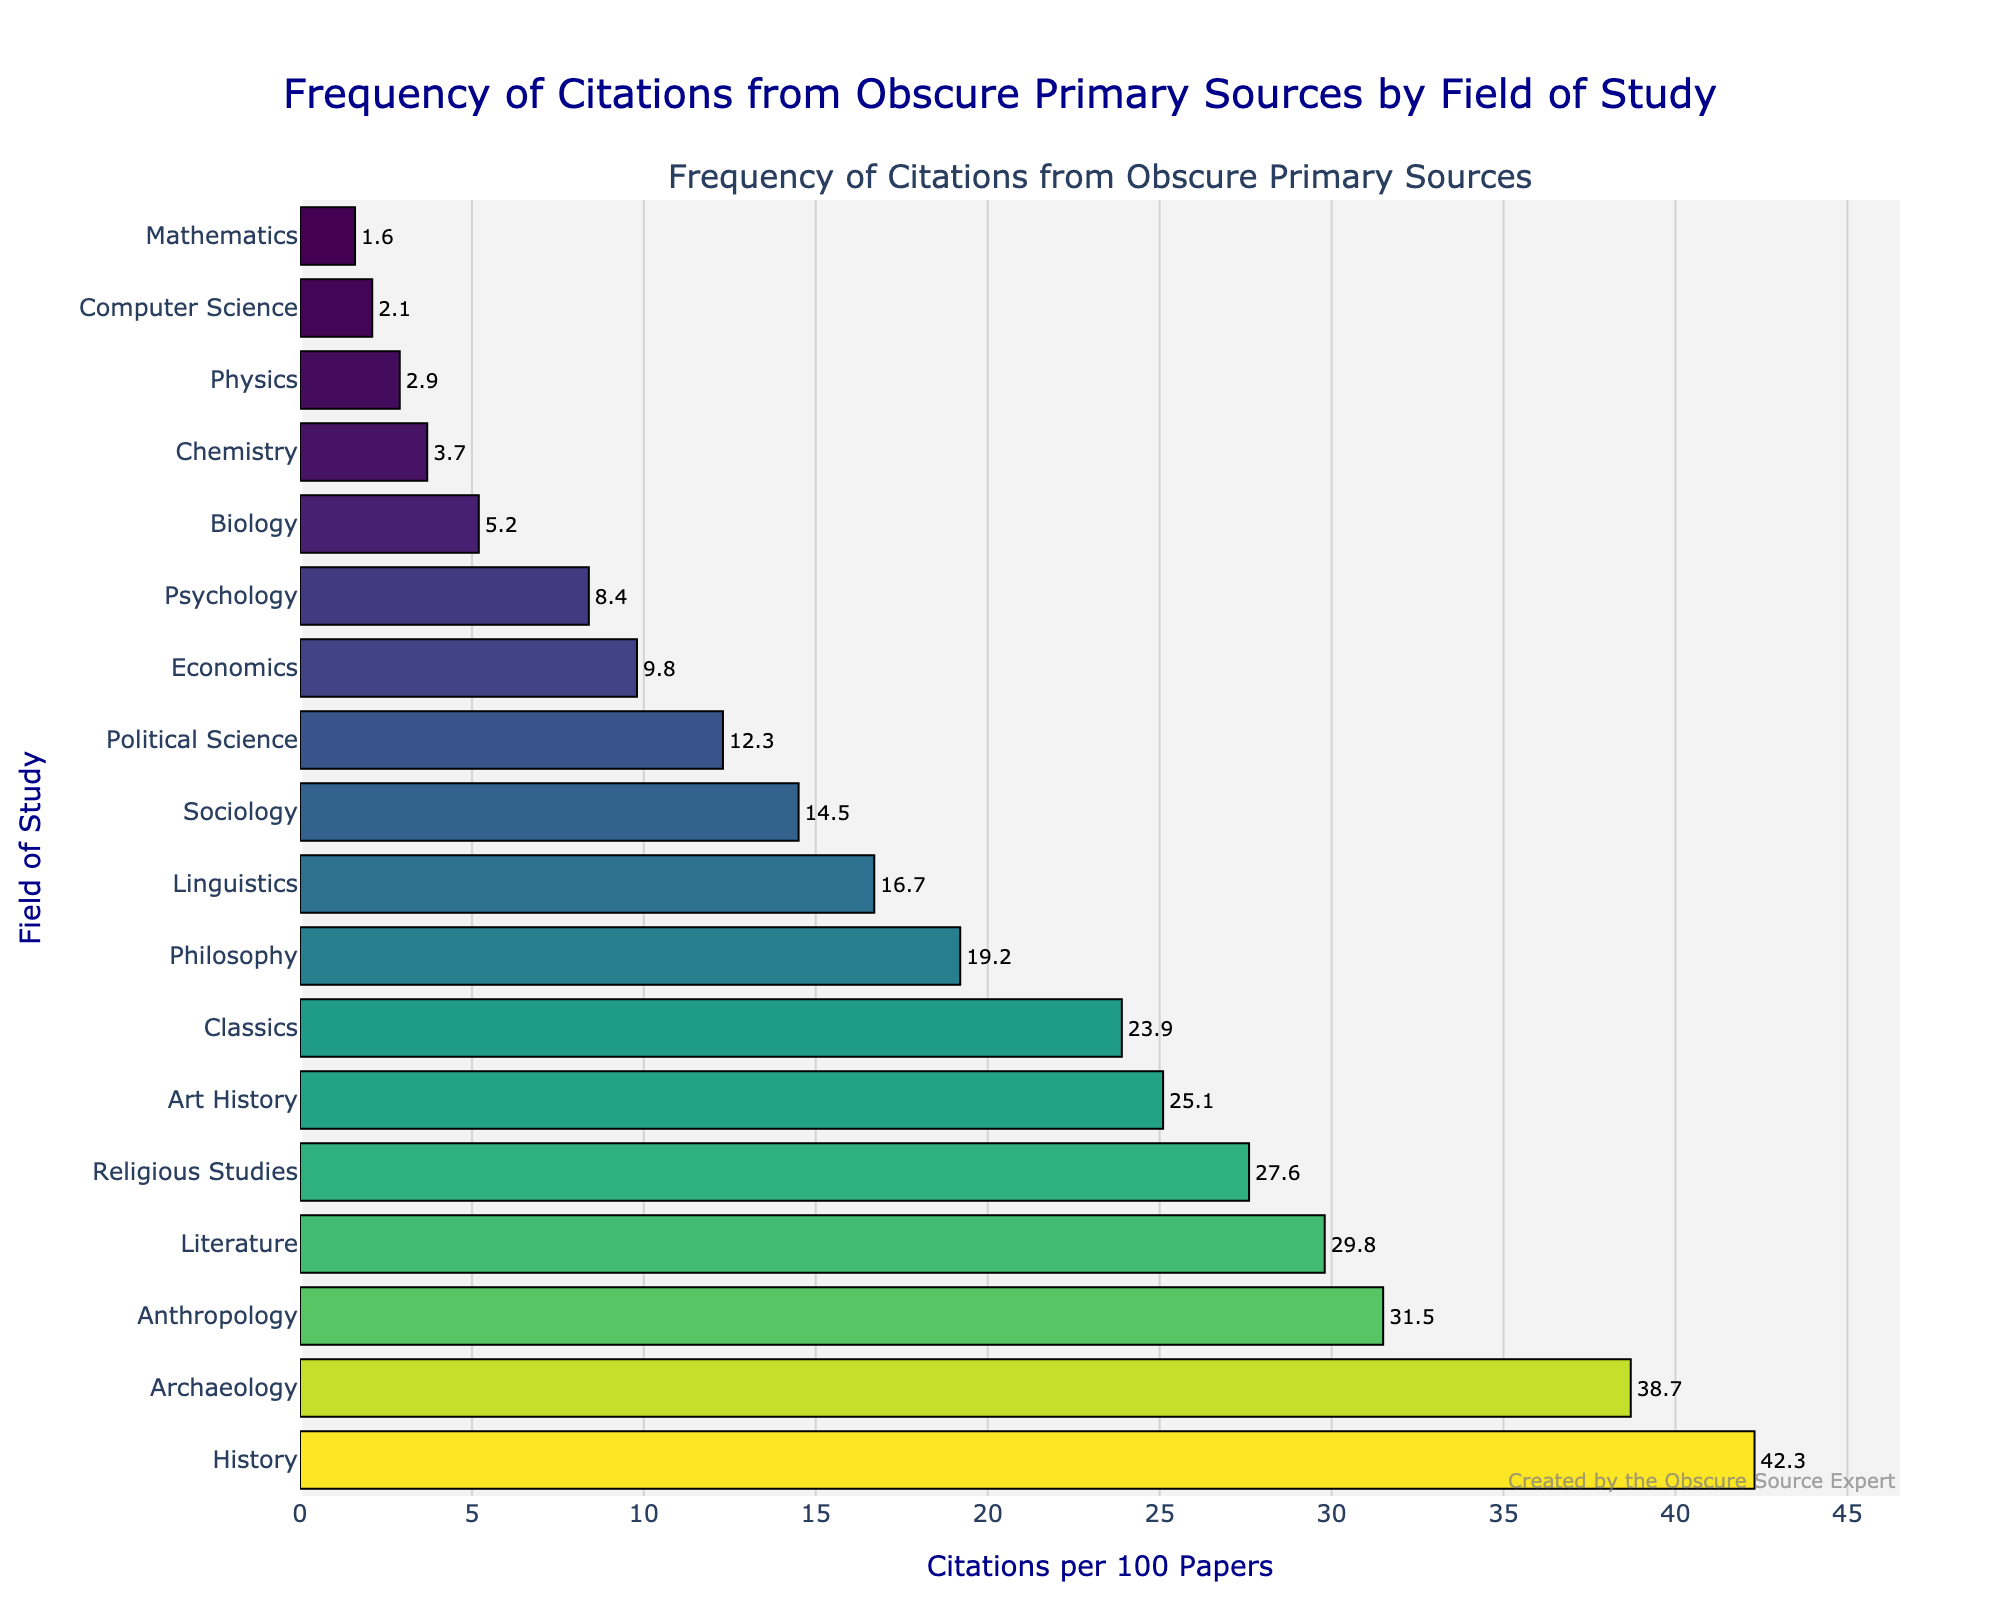What field has the highest frequency of citations from obscure primary sources? The field with the highest bar on the chart represents the highest frequency of citations per 100 papers. By looking at the chart, History has the tallest bar.
Answer: History What's the difference in citation frequency between Anthropology and Sociology? Find the citation frequency for Anthropology and Sociology, then subtract the smaller value from the larger one: Anthropology has 31.5 citations per 100 papers, Sociology has 14.5. Therefore, the difference is 31.5 - 14.5.
Answer: 17 Which field relies least on obscure primary sources according to the chart? Identify the field with the shortest bar on the chart. Mathematics has the shortest bar.
Answer: Mathematics How many fields have a citation frequency greater than 20 per 100 papers? Count the number of fields with bars that correspond to citation values above 20. The fields are History, Archaeology, Anthropology, Literature, and Religious Studies, making it 5 fields.
Answer: 5 What is the median citation frequency across all the fields? List all citation frequencies in ascending order and find the middle value. The sorted frequencies are: 1.6, 2.1, 2.9, 3.7, 5.2, 8.4, 9.8, 12.3, 14.5, 16.7, 19.2, 23.9, 25.1, 27.6, 29.8, 31.5, 38.7, 42.3. With 18 values, the median is the average of the 9th and 10th values: (14.5 + 16.7) / 2.
Answer: 15.6 By how much does the citation frequency in Philosophy exceed that in Chemistry? Find the citation frequencies for both fields and subtract the smaller value from the larger one. Philosophy has 19.2 citations, and Chemistry has 3.7 citations; the difference is 19.2 - 3.7.
Answer: 15.5 Which fields have a citation frequency less than half of the citation frequency of Archaeology? First, calculate half of Archaeology's frequency: 38.7 / 2 = 19.35. Then, identify fields with citation frequencies below 19.35. They are Linguistics, Sociology, Political Science, Economics, Psychology, Biology, Chemistry, Physics, Computer Science, and Mathematics.
Answer: 10 fields What's the average citation frequency of the fields Religious Studies, Art History, and Classics? Add the citation frequencies for these fields and divide by 3. Religious Studies: 27.6, Art History: 25.1, Classics: 23.9. The sum is 27.6 + 25.1 + 23.9 = 76.6, and the average is 76.6 / 3.
Answer: 25.53 Which field shows a frequency closest to the overall average of citation frequencies for all fields? Calculate the overall average by summing all citation frequencies and dividing by the number of fields. The sum is 317.2, and there are 18 fields, so the average is 317.2 / 18 ≈ 17.62. The closest field to this value is Linguistics with 16.7.
Answer: Linguistics 